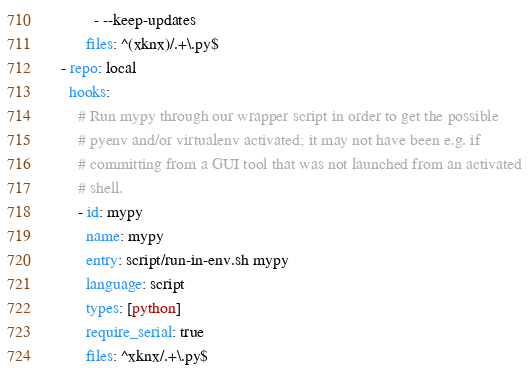Convert code to text. <code><loc_0><loc_0><loc_500><loc_500><_YAML_>          - --keep-updates
        files: ^(xknx)/.+\.py$
  - repo: local
    hooks:
      # Run mypy through our wrapper script in order to get the possible
      # pyenv and/or virtualenv activated; it may not have been e.g. if
      # committing from a GUI tool that was not launched from an activated
      # shell.
      - id: mypy
        name: mypy
        entry: script/run-in-env.sh mypy
        language: script
        types: [python]
        require_serial: true
        files: ^xknx/.+\.py$
</code> 